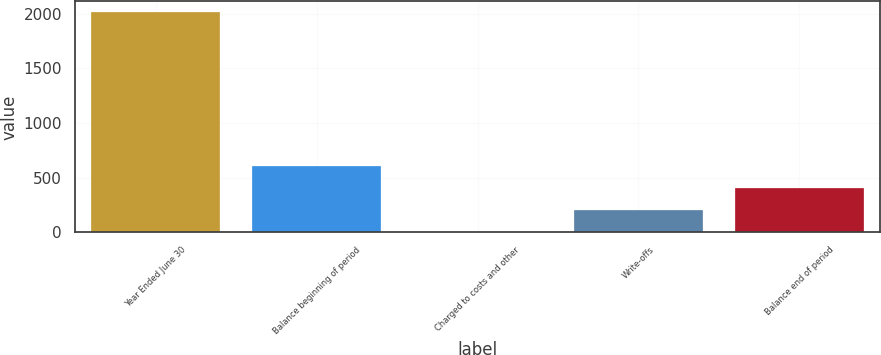Convert chart to OTSL. <chart><loc_0><loc_0><loc_500><loc_500><bar_chart><fcel>Year Ended June 30<fcel>Balance beginning of period<fcel>Charged to costs and other<fcel>Write-offs<fcel>Balance end of period<nl><fcel>2013<fcel>606.7<fcel>4<fcel>204.9<fcel>405.8<nl></chart> 